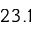Convert formula to latex. <formula><loc_0><loc_0><loc_500><loc_500>2 3 . 1</formula> 